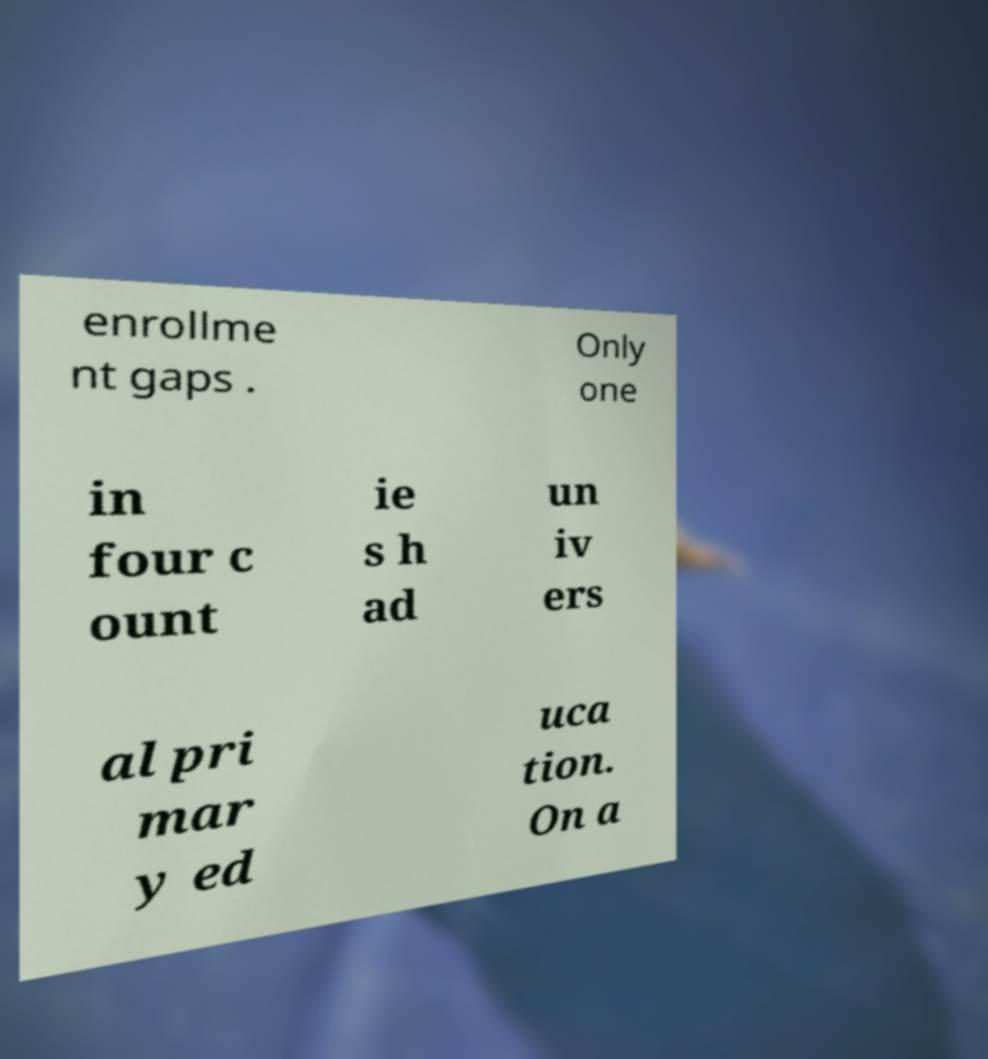Please read and relay the text visible in this image. What does it say? enrollme nt gaps . Only one in four c ount ie s h ad un iv ers al pri mar y ed uca tion. On a 